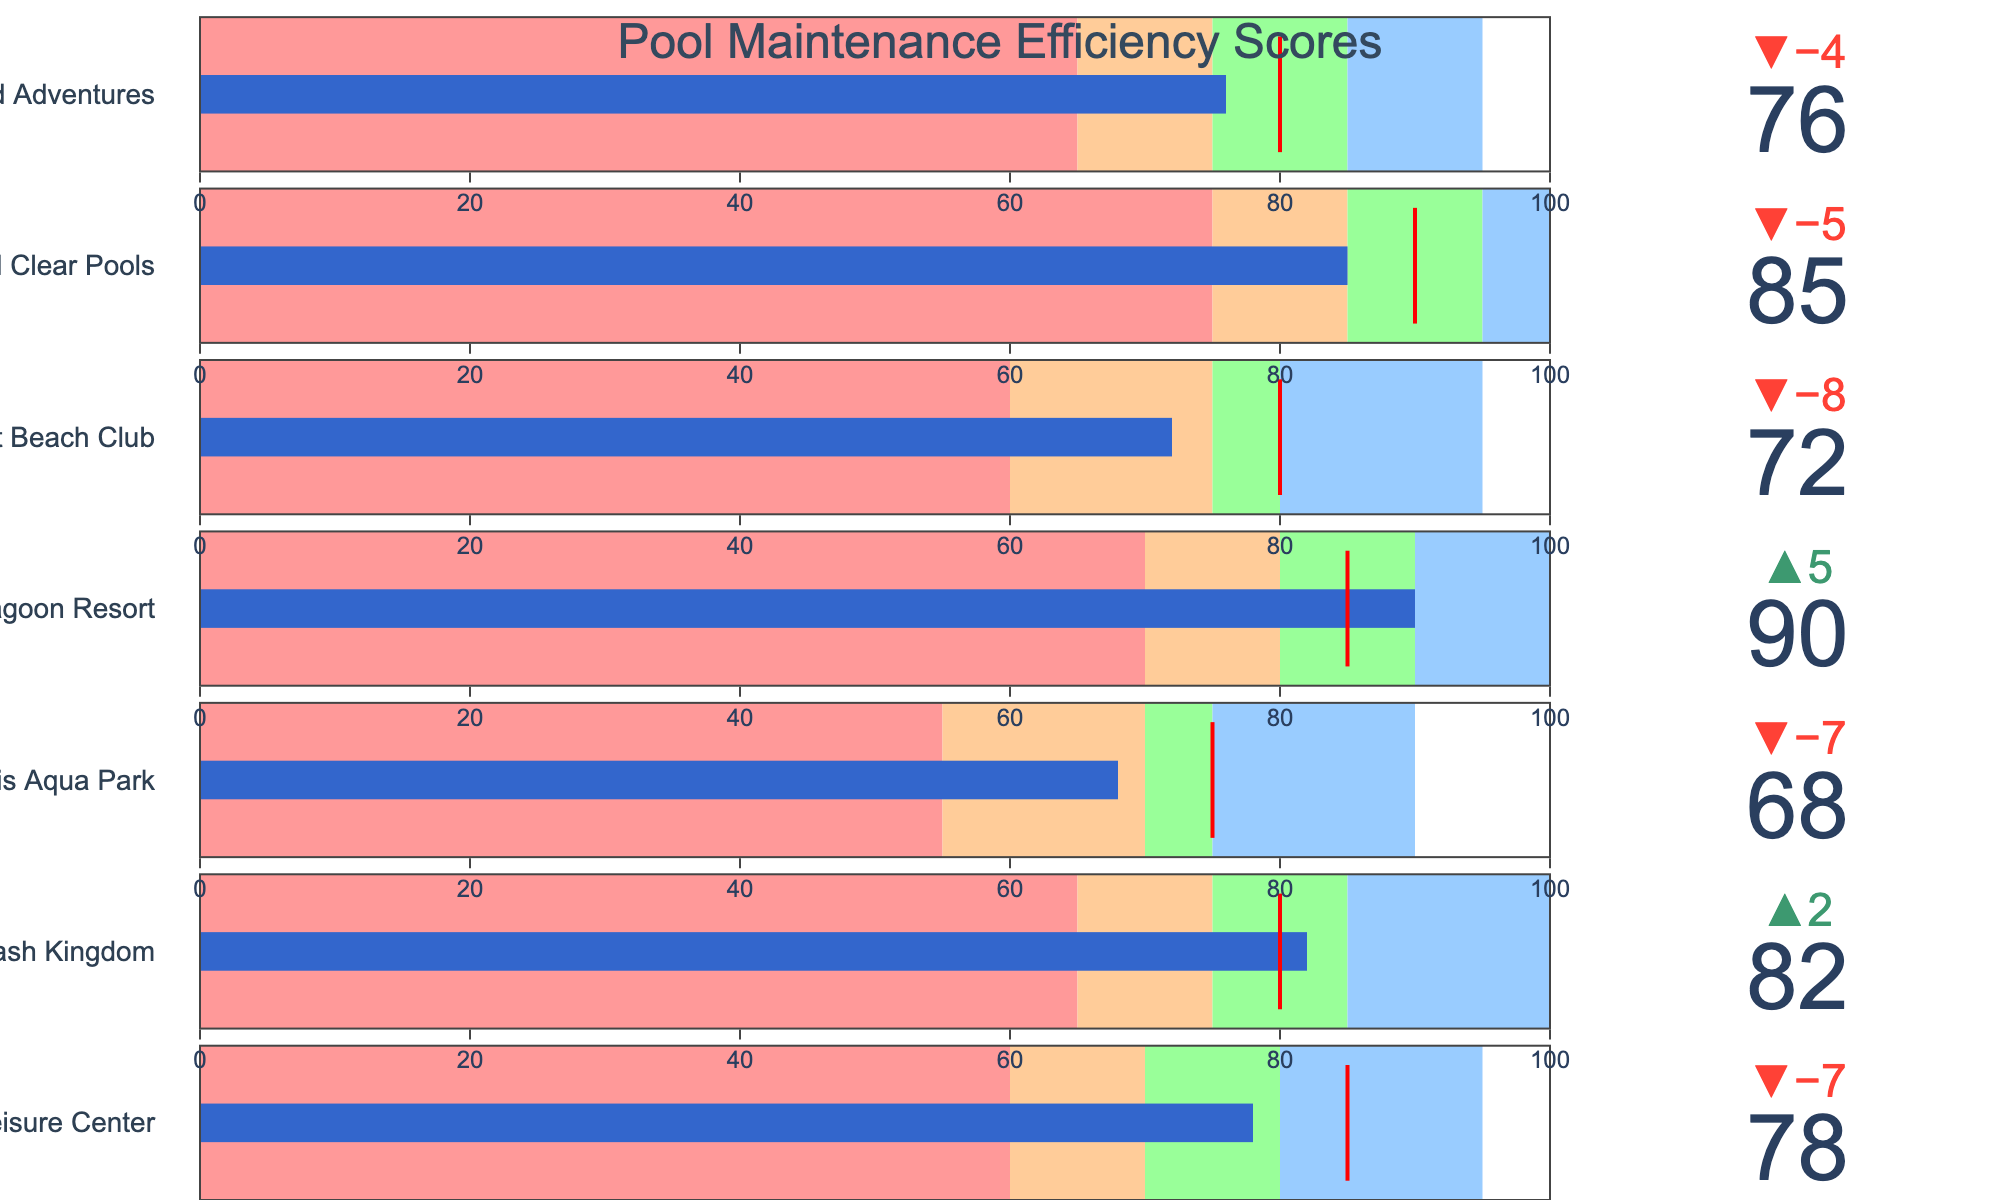What's the title of the chart? The title of the chart is displayed at the top of the figure and reads "Pool Maintenance Efficiency Scores".
Answer: Pool Maintenance Efficiency Scores What's the efficiency score of Crystal Clear Pools? Locate "Crystal Clear Pools" on the chart and find the value indicated for Efficiency Score. It's represented by a number within the gauge, which is 85.
Answer: 85 Which pool has the lowest efficiency score? Compare the Efficiency Scores of all listed pools and find the minimum value. The lowest efficiency score is for Oasis Aqua Park with a score of 68.
Answer: Oasis Aqua Park Which two pools have the exact same target value? Analyze the Target values for all pools and identify the pools with matching targets. Both Aquatica Leisure Center and Blue Lagoon Resort have a target value of 85.
Answer: Aquatica Leisure Center and Blue Lagoon Resort Is Blue Lagoon Resort's efficiency score above or below its target? Compare Blue Lagoon Resort's Efficiency Score (90) with its Target (85). Since 90 is greater than 85, it's above the target.
Answer: Above How many pools achieved an efficiency score in the "Good" range or higher? Evaluate the Efficiency Scores and see if they reach or exceed the threshold for "Good" in their respective pools. Five pools (Splash Kingdom, Blue Lagoon Resort, Crystal Clear Pools, Aquatica Leisure Center, and Waterworld Adventures) meet or exceed the "Good" range.
Answer: Five What's the average efficiency score of all pools? Sum the efficiency scores and divide by the number of pools. 
(78 + 82 + 68 + 90 + 72+ 85 + 76) / 7 = 551 / 7 = 78.71
Answer: 78.71 Which pool has the largest difference between its efficiency score and its target? Calculate the absolute difference between the Efficiency Score and Target for each pool, and find the maximum difference. Oasis Aqua Park has the largest difference of 7 (75 - 68 = 7).
Answer: Oasis Aqua Park Are there any pools that have exactly met their target? Compare the Efficiency Scores with the Target values directly to check for matches. None of the pools have exactly met their target efficiency score.
Answer: No 